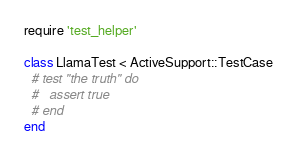<code> <loc_0><loc_0><loc_500><loc_500><_Ruby_>require 'test_helper'

class LlamaTest < ActiveSupport::TestCase
  # test "the truth" do
  #   assert true
  # end
end
</code> 